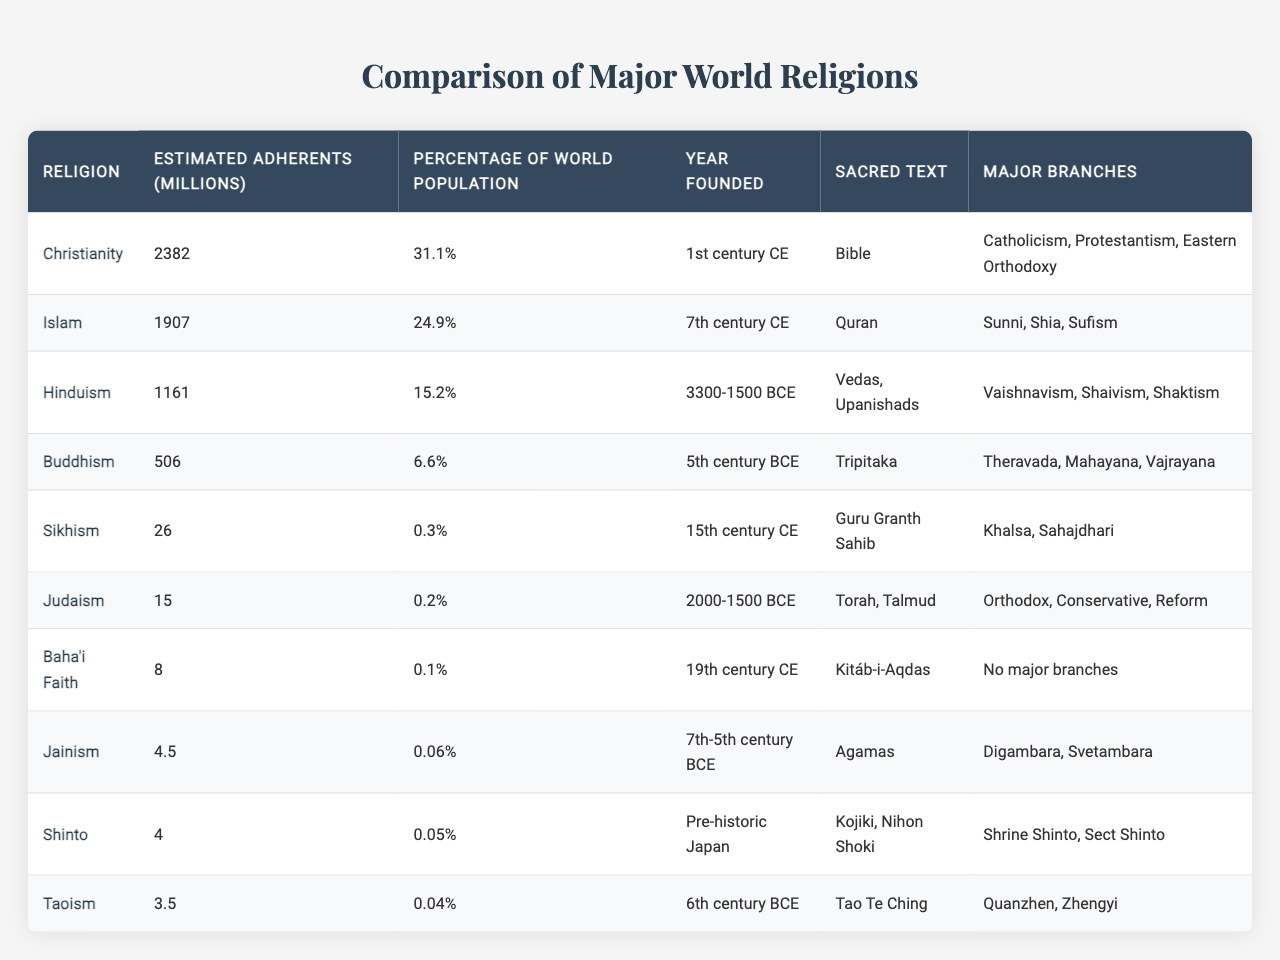What is the religion with the highest estimated number of adherents? The table indicates that Christianity has the highest number of estimated adherents, with 2382 million.
Answer: Christianity Which religion was founded in the 15th century CE? By referring to the "Year Founded" column, it can be identified that Sikhism was founded in the 15th century CE.
Answer: Sikhism What percentage of the world population adheres to Buddhism? The table shows that Buddhism represents 6.6% of the world population, as stated in the "Percentage of World Population" column.
Answer: 6.6% How many adherents does Islam have compared to Hinduism? Islam has 1907 million adherents while Hinduism has 1161 million adherents. The difference is calculated by subtracting the latter from the former: 1907 - 1161 = 746 million.
Answer: 746 million Which two religions have the least estimated number of adherents? Looking at the "Estimated Adherents (millions)" column, Jainism (4.5 million) and Taoism (3.5 million) have the least adherents.
Answer: Jainism and Taoism What is the combined number of adherents for Judaism and Baha'i Faith? Judaism has 15 million adherents and Baha'i Faith has 8 million. The sum is calculated as follows: 15 + 8 = 23 million.
Answer: 23 million Is it true that Shinto has a larger percentage of world population adherents than Judaism? Comparing the percentages, Shinto has 0.05% while Judaism has 0.2%. Since 0.05% is less than 0.2%, the statement is false.
Answer: No Which religion has the most number of major branches? By examining the "Major Branches" column, it is noted that Christianity has three major branches: Catholicism, Protestantism, and Eastern Orthodoxy, more so than any other religion listed.
Answer: Christianity What is the average number of adherents (in millions) among the listed religions? To find the average, sum the total number of adherents (2382 + 1907 + 1161 + 506 + 26 + 15 + 8 + 4.5 + 4 + 3.5 = 4592 million) and divide by the total number of religions (10): 4592 / 10 = 459.2 million.
Answer: 459.2 million Which sacred text is associated with Islam? The "Sacred Text" column specifies that the Quran is the sacred text associated with Islam.
Answer: Quran 